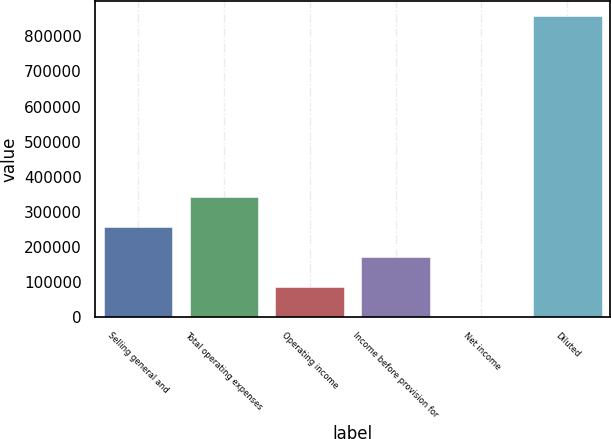Convert chart. <chart><loc_0><loc_0><loc_500><loc_500><bar_chart><fcel>Selling general and<fcel>Total operating expenses<fcel>Operating income<fcel>Income before provision for<fcel>Net income<fcel>Diluted<nl><fcel>257306<fcel>342978<fcel>85962.1<fcel>171634<fcel>290<fcel>857011<nl></chart> 